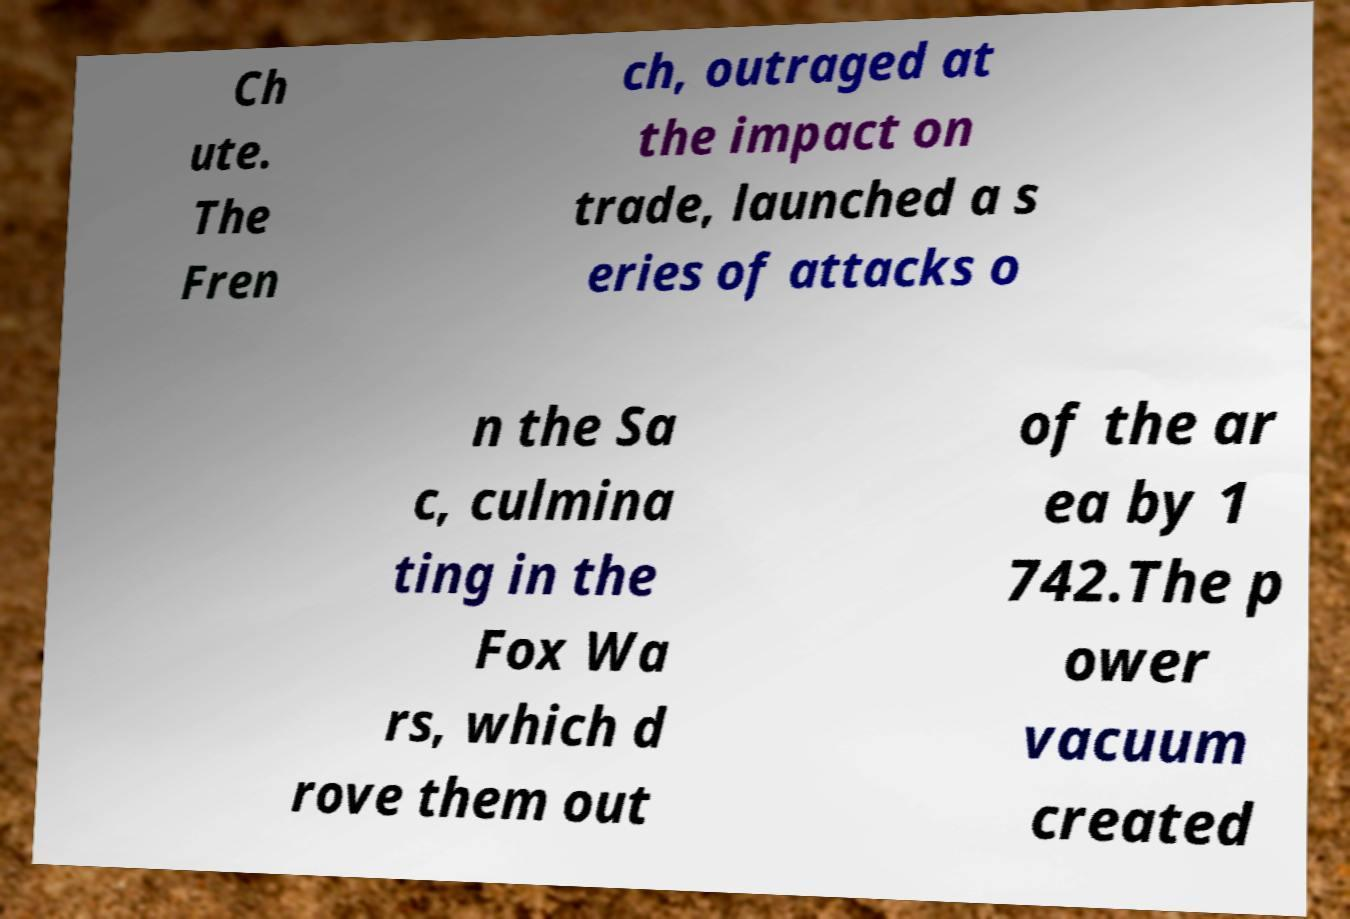Could you extract and type out the text from this image? Ch ute. The Fren ch, outraged at the impact on trade, launched a s eries of attacks o n the Sa c, culmina ting in the Fox Wa rs, which d rove them out of the ar ea by 1 742.The p ower vacuum created 